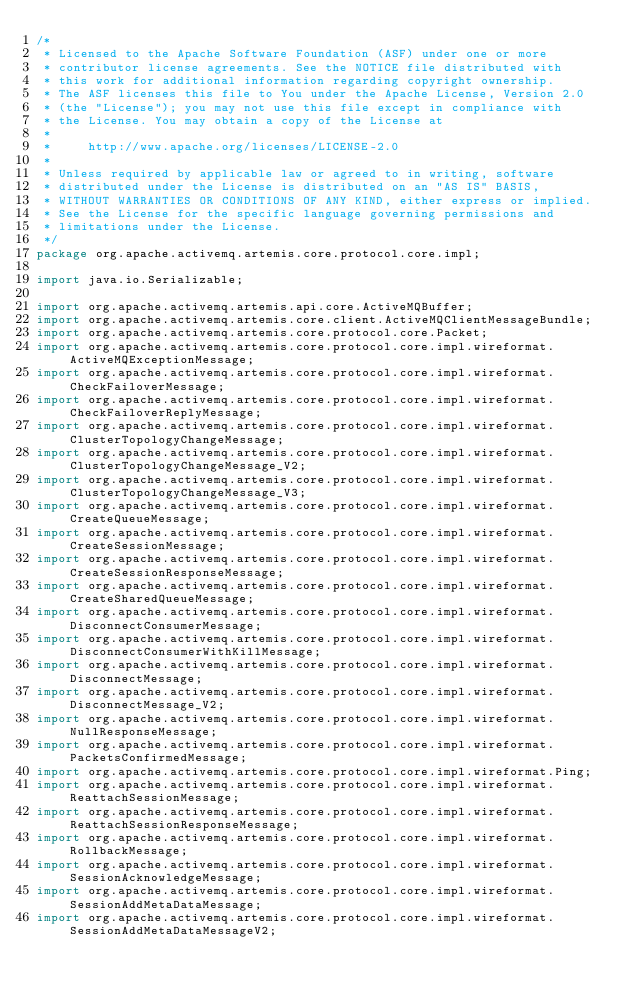<code> <loc_0><loc_0><loc_500><loc_500><_Java_>/*
 * Licensed to the Apache Software Foundation (ASF) under one or more
 * contributor license agreements. See the NOTICE file distributed with
 * this work for additional information regarding copyright ownership.
 * The ASF licenses this file to You under the Apache License, Version 2.0
 * (the "License"); you may not use this file except in compliance with
 * the License. You may obtain a copy of the License at
 *
 *     http://www.apache.org/licenses/LICENSE-2.0
 *
 * Unless required by applicable law or agreed to in writing, software
 * distributed under the License is distributed on an "AS IS" BASIS,
 * WITHOUT WARRANTIES OR CONDITIONS OF ANY KIND, either express or implied.
 * See the License for the specific language governing permissions and
 * limitations under the License.
 */
package org.apache.activemq.artemis.core.protocol.core.impl;

import java.io.Serializable;

import org.apache.activemq.artemis.api.core.ActiveMQBuffer;
import org.apache.activemq.artemis.core.client.ActiveMQClientMessageBundle;
import org.apache.activemq.artemis.core.protocol.core.Packet;
import org.apache.activemq.artemis.core.protocol.core.impl.wireformat.ActiveMQExceptionMessage;
import org.apache.activemq.artemis.core.protocol.core.impl.wireformat.CheckFailoverMessage;
import org.apache.activemq.artemis.core.protocol.core.impl.wireformat.CheckFailoverReplyMessage;
import org.apache.activemq.artemis.core.protocol.core.impl.wireformat.ClusterTopologyChangeMessage;
import org.apache.activemq.artemis.core.protocol.core.impl.wireformat.ClusterTopologyChangeMessage_V2;
import org.apache.activemq.artemis.core.protocol.core.impl.wireformat.ClusterTopologyChangeMessage_V3;
import org.apache.activemq.artemis.core.protocol.core.impl.wireformat.CreateQueueMessage;
import org.apache.activemq.artemis.core.protocol.core.impl.wireformat.CreateSessionMessage;
import org.apache.activemq.artemis.core.protocol.core.impl.wireformat.CreateSessionResponseMessage;
import org.apache.activemq.artemis.core.protocol.core.impl.wireformat.CreateSharedQueueMessage;
import org.apache.activemq.artemis.core.protocol.core.impl.wireformat.DisconnectConsumerMessage;
import org.apache.activemq.artemis.core.protocol.core.impl.wireformat.DisconnectConsumerWithKillMessage;
import org.apache.activemq.artemis.core.protocol.core.impl.wireformat.DisconnectMessage;
import org.apache.activemq.artemis.core.protocol.core.impl.wireformat.DisconnectMessage_V2;
import org.apache.activemq.artemis.core.protocol.core.impl.wireformat.NullResponseMessage;
import org.apache.activemq.artemis.core.protocol.core.impl.wireformat.PacketsConfirmedMessage;
import org.apache.activemq.artemis.core.protocol.core.impl.wireformat.Ping;
import org.apache.activemq.artemis.core.protocol.core.impl.wireformat.ReattachSessionMessage;
import org.apache.activemq.artemis.core.protocol.core.impl.wireformat.ReattachSessionResponseMessage;
import org.apache.activemq.artemis.core.protocol.core.impl.wireformat.RollbackMessage;
import org.apache.activemq.artemis.core.protocol.core.impl.wireformat.SessionAcknowledgeMessage;
import org.apache.activemq.artemis.core.protocol.core.impl.wireformat.SessionAddMetaDataMessage;
import org.apache.activemq.artemis.core.protocol.core.impl.wireformat.SessionAddMetaDataMessageV2;</code> 